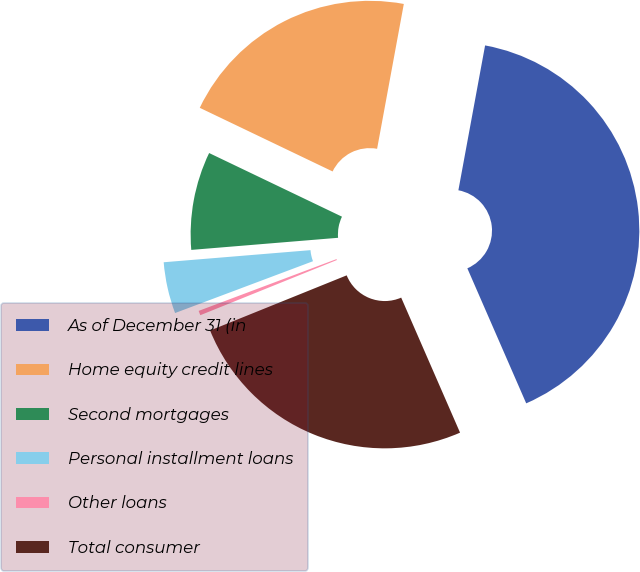Convert chart. <chart><loc_0><loc_0><loc_500><loc_500><pie_chart><fcel>As of December 31 (in<fcel>Home equity credit lines<fcel>Second mortgages<fcel>Personal installment loans<fcel>Other loans<fcel>Total consumer<nl><fcel>40.55%<fcel>20.79%<fcel>8.42%<fcel>4.41%<fcel>0.39%<fcel>25.43%<nl></chart> 